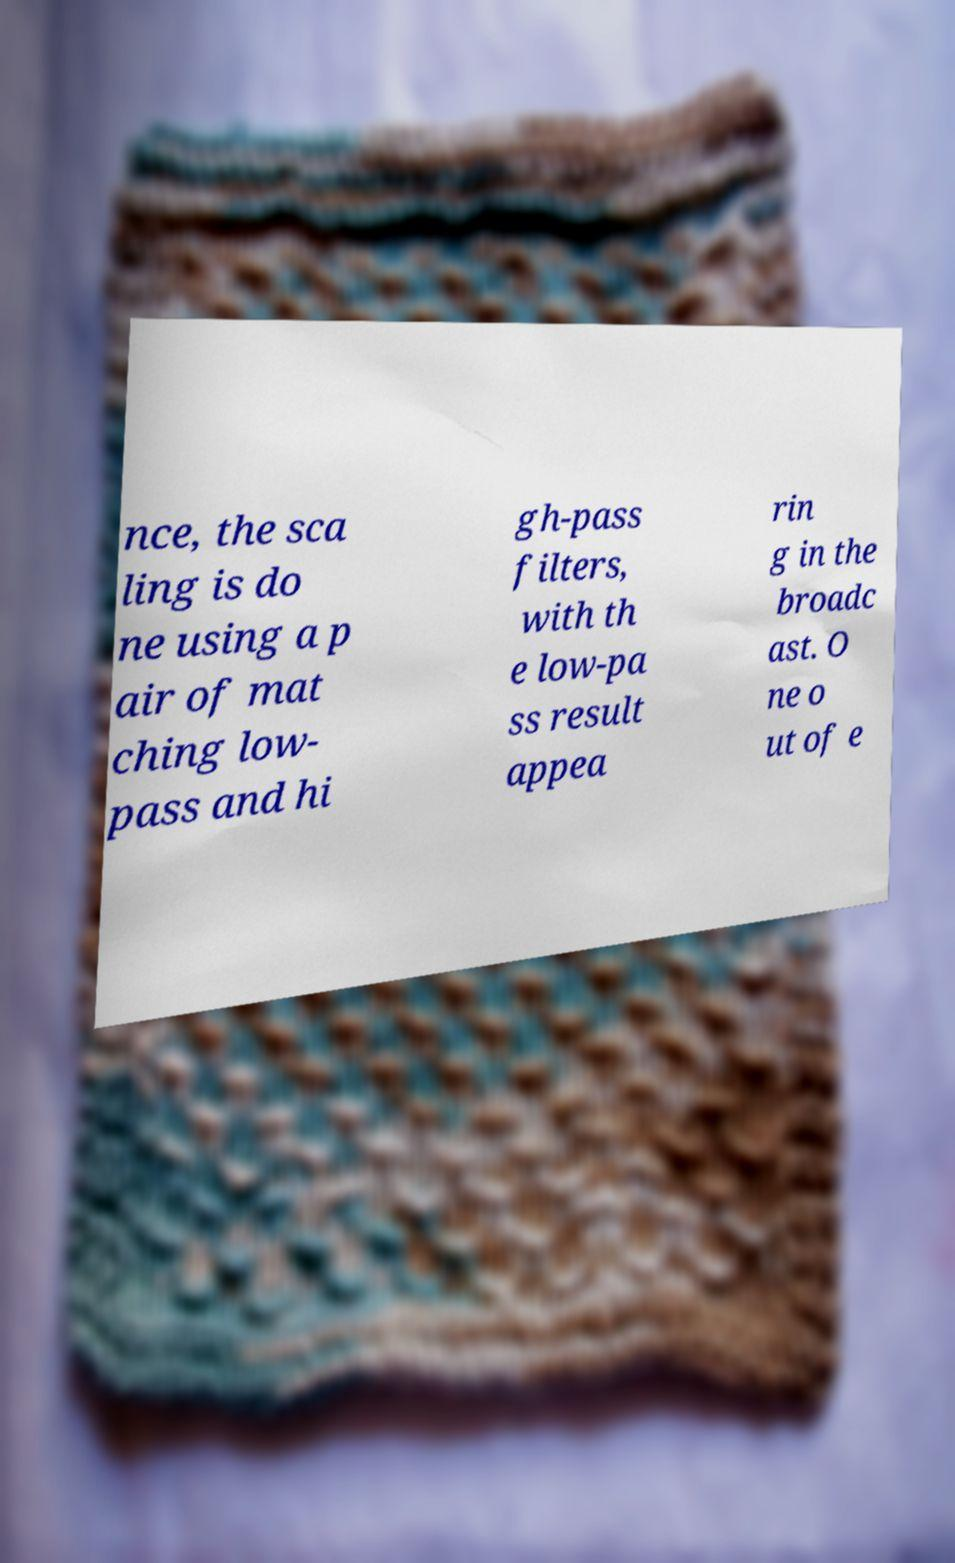For documentation purposes, I need the text within this image transcribed. Could you provide that? nce, the sca ling is do ne using a p air of mat ching low- pass and hi gh-pass filters, with th e low-pa ss result appea rin g in the broadc ast. O ne o ut of e 